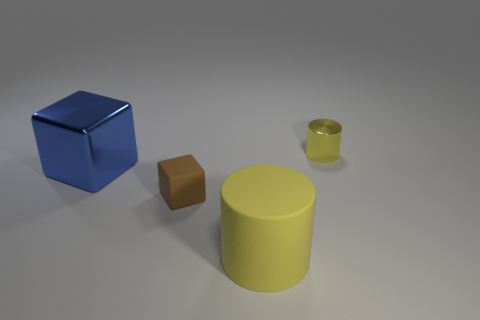There is a cylinder that is the same size as the brown thing; what material is it?
Ensure brevity in your answer.  Metal. What number of purple shiny spheres are there?
Provide a succinct answer. 0. What size is the yellow object that is behind the rubber block?
Your response must be concise. Small. Are there an equal number of big things that are behind the small rubber cube and rubber cubes?
Provide a short and direct response. Yes. Is there another big yellow rubber thing that has the same shape as the large yellow object?
Keep it short and to the point. No. What shape is the object that is left of the big rubber cylinder and on the right side of the large blue object?
Give a very brief answer. Cube. Is the large blue block made of the same material as the big object to the right of the metallic block?
Your answer should be very brief. No. There is a large cube; are there any tiny rubber blocks on the right side of it?
Keep it short and to the point. Yes. How many objects are blue cubes or brown things to the left of the large yellow matte cylinder?
Offer a very short reply. 2. The tiny thing left of the shiny object on the right side of the big blue shiny object is what color?
Your response must be concise. Brown. 